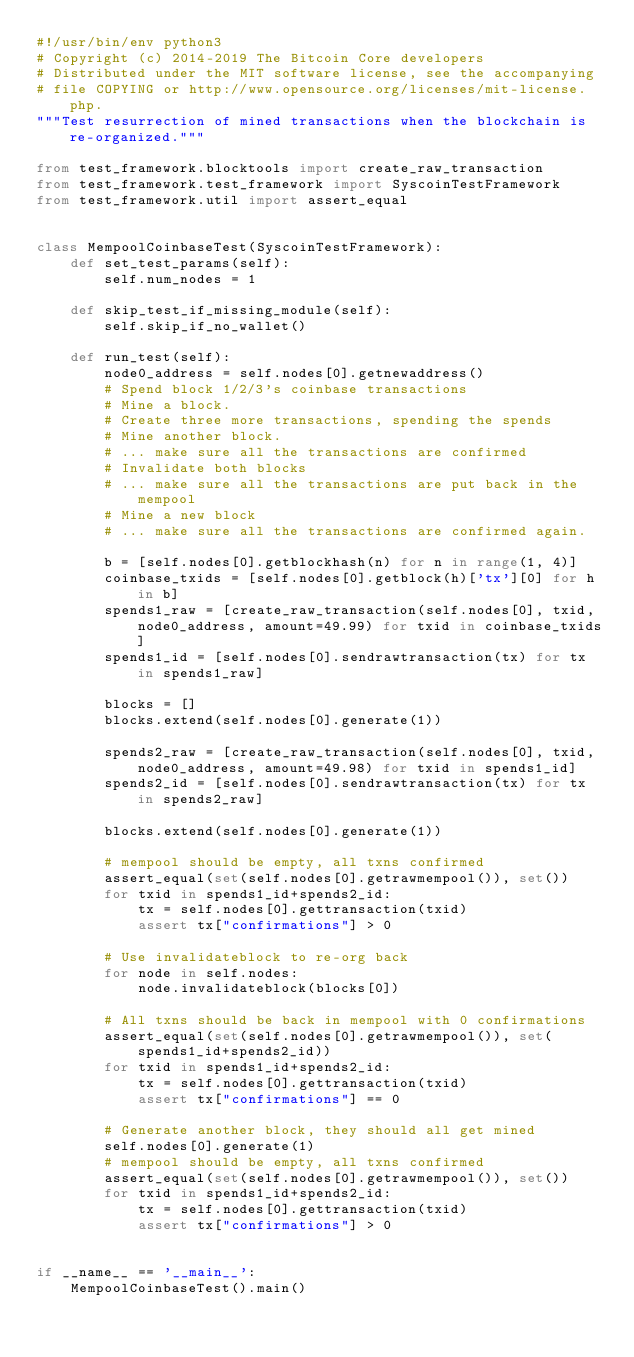Convert code to text. <code><loc_0><loc_0><loc_500><loc_500><_Python_>#!/usr/bin/env python3
# Copyright (c) 2014-2019 The Bitcoin Core developers
# Distributed under the MIT software license, see the accompanying
# file COPYING or http://www.opensource.org/licenses/mit-license.php.
"""Test resurrection of mined transactions when the blockchain is re-organized."""

from test_framework.blocktools import create_raw_transaction
from test_framework.test_framework import SyscoinTestFramework
from test_framework.util import assert_equal


class MempoolCoinbaseTest(SyscoinTestFramework):
    def set_test_params(self):
        self.num_nodes = 1

    def skip_test_if_missing_module(self):
        self.skip_if_no_wallet()

    def run_test(self):
        node0_address = self.nodes[0].getnewaddress()
        # Spend block 1/2/3's coinbase transactions
        # Mine a block.
        # Create three more transactions, spending the spends
        # Mine another block.
        # ... make sure all the transactions are confirmed
        # Invalidate both blocks
        # ... make sure all the transactions are put back in the mempool
        # Mine a new block
        # ... make sure all the transactions are confirmed again.

        b = [self.nodes[0].getblockhash(n) for n in range(1, 4)]
        coinbase_txids = [self.nodes[0].getblock(h)['tx'][0] for h in b]
        spends1_raw = [create_raw_transaction(self.nodes[0], txid, node0_address, amount=49.99) for txid in coinbase_txids]
        spends1_id = [self.nodes[0].sendrawtransaction(tx) for tx in spends1_raw]

        blocks = []
        blocks.extend(self.nodes[0].generate(1))

        spends2_raw = [create_raw_transaction(self.nodes[0], txid, node0_address, amount=49.98) for txid in spends1_id]
        spends2_id = [self.nodes[0].sendrawtransaction(tx) for tx in spends2_raw]

        blocks.extend(self.nodes[0].generate(1))

        # mempool should be empty, all txns confirmed
        assert_equal(set(self.nodes[0].getrawmempool()), set())
        for txid in spends1_id+spends2_id:
            tx = self.nodes[0].gettransaction(txid)
            assert tx["confirmations"] > 0

        # Use invalidateblock to re-org back
        for node in self.nodes:
            node.invalidateblock(blocks[0])

        # All txns should be back in mempool with 0 confirmations
        assert_equal(set(self.nodes[0].getrawmempool()), set(spends1_id+spends2_id))
        for txid in spends1_id+spends2_id:
            tx = self.nodes[0].gettransaction(txid)
            assert tx["confirmations"] == 0

        # Generate another block, they should all get mined
        self.nodes[0].generate(1)
        # mempool should be empty, all txns confirmed
        assert_equal(set(self.nodes[0].getrawmempool()), set())
        for txid in spends1_id+spends2_id:
            tx = self.nodes[0].gettransaction(txid)
            assert tx["confirmations"] > 0


if __name__ == '__main__':
    MempoolCoinbaseTest().main()
</code> 